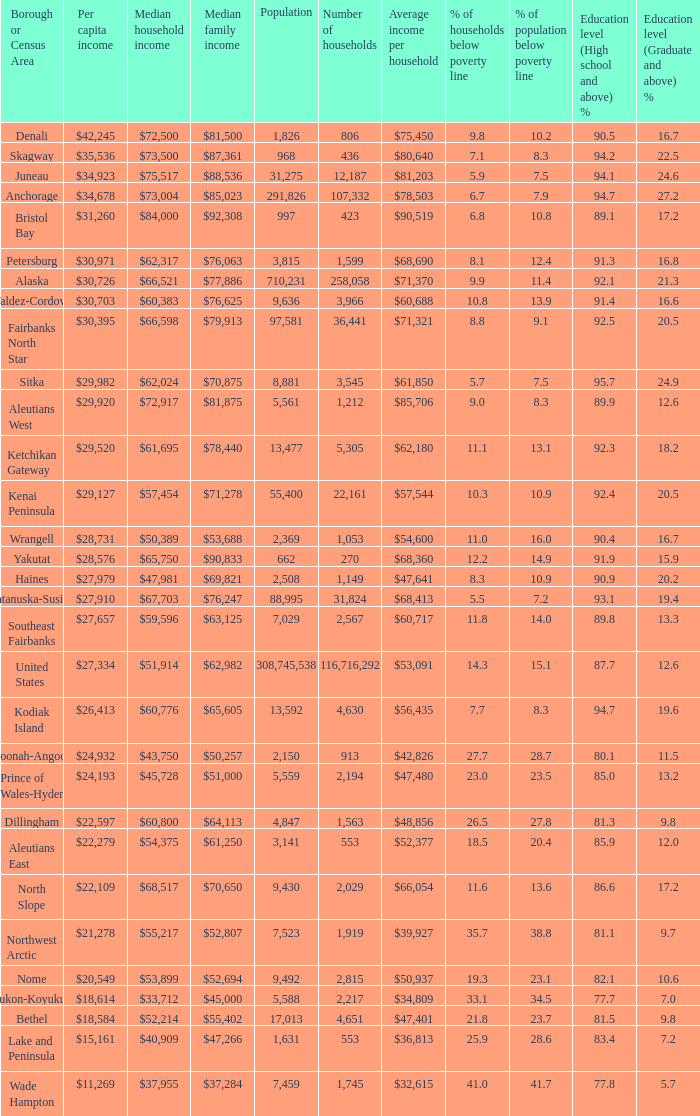Which borough or census area has a $59,596 median household income? Southeast Fairbanks. 